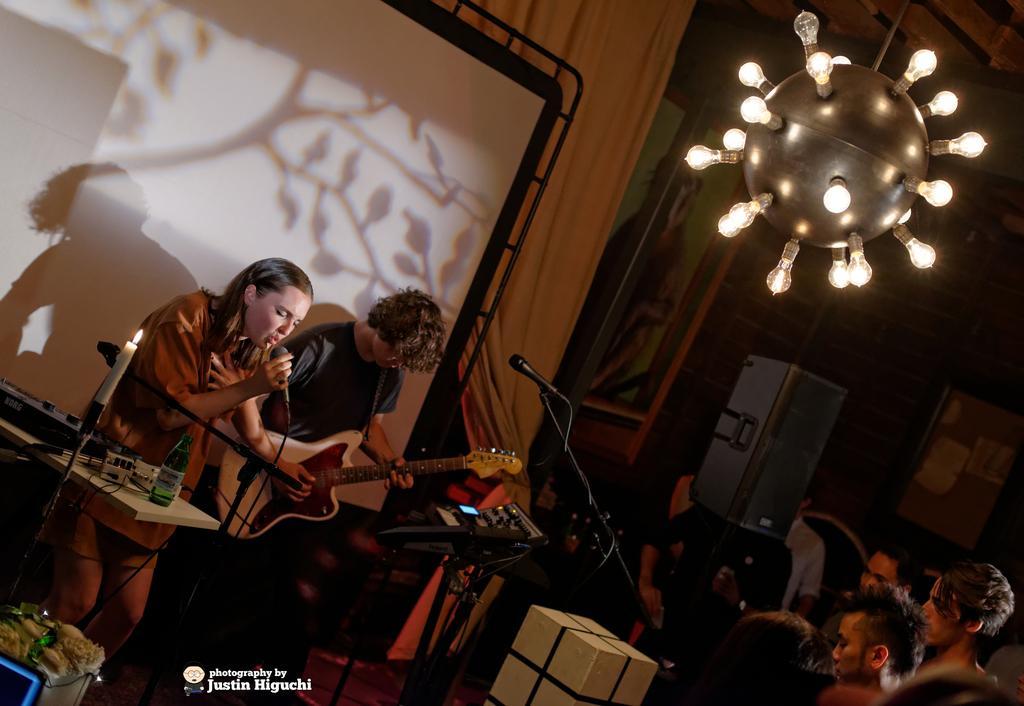In one or two sentences, can you explain what this image depicts? there are many people in a room. at the left people are standing and singing. the person at the left is holding a microphone and a person to her right is playing a white and red guitar. behind them there is a white screen and curtains. at the right people are standing and listening to them. at the top there is a chandelier which has many bulbs. in the left front there is a table on which there is a green bottle and a candle is lit. 